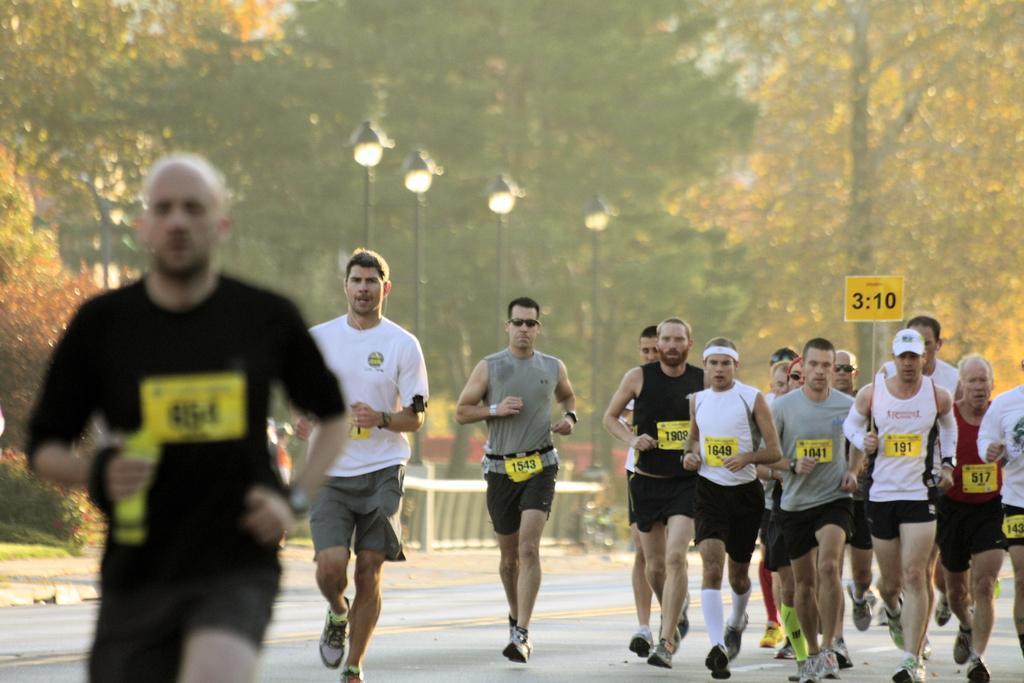How would you summarize this image in a sentence or two? In the image we can see there are many people running. They are wearing clothes, socks, shoes and some of them are wearing goggles. Here we can see the road, light poles and trees. We can even see the background is slightly blurred. 